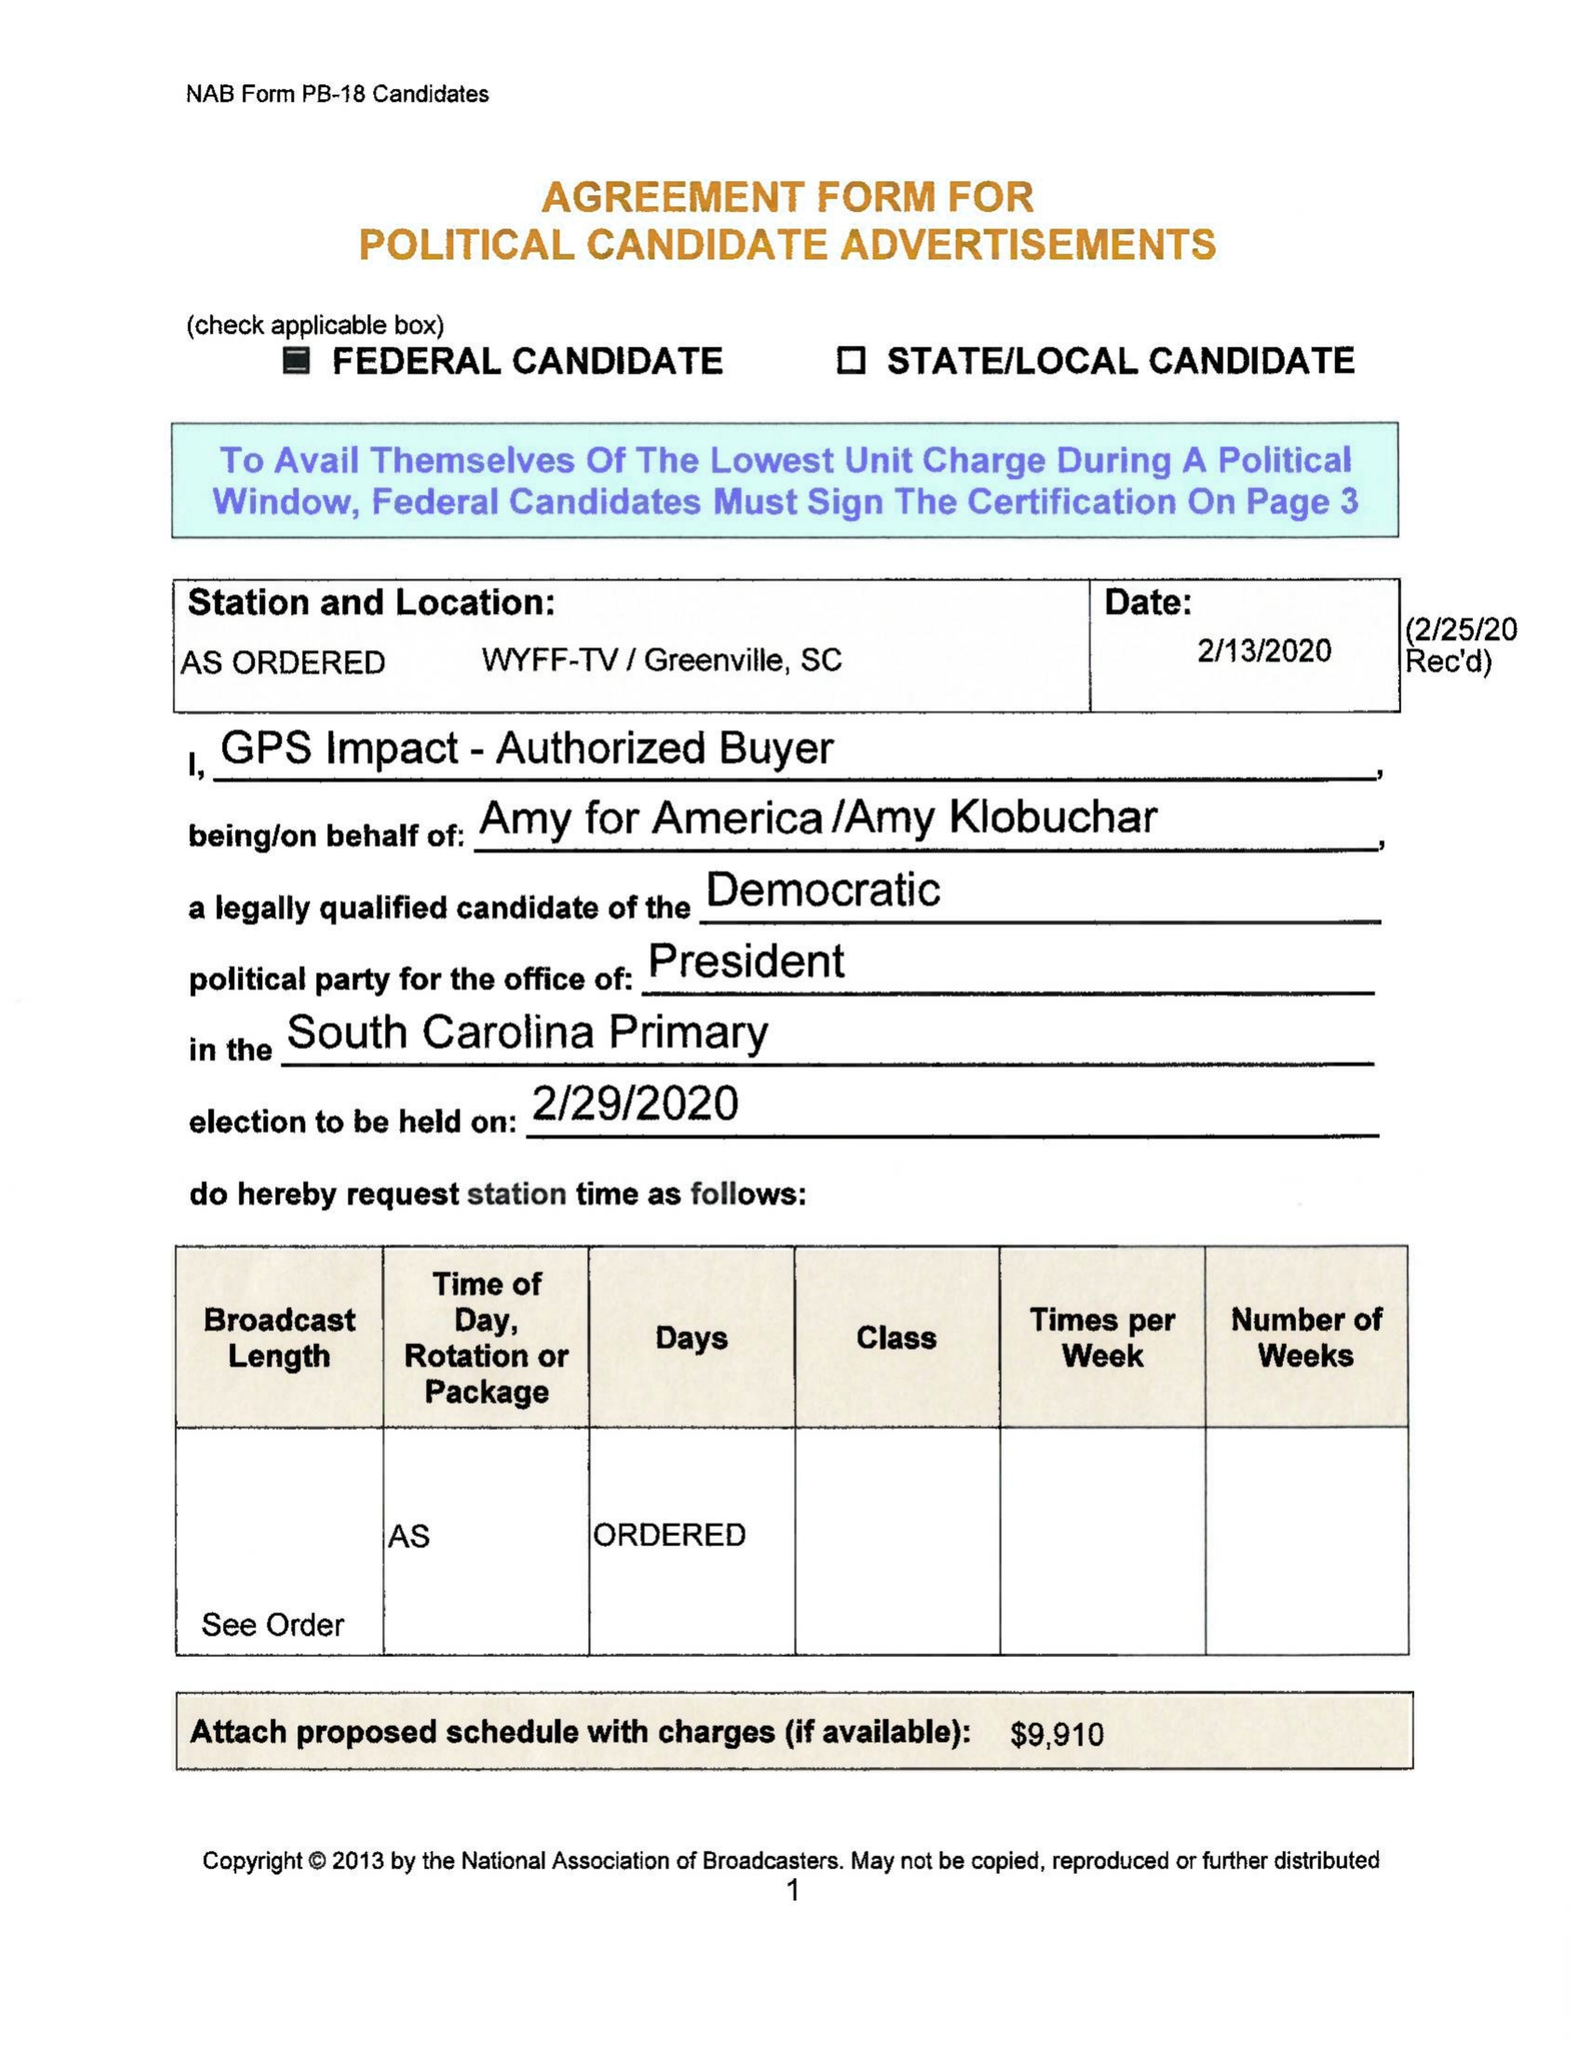What is the value for the flight_from?
Answer the question using a single word or phrase. None 